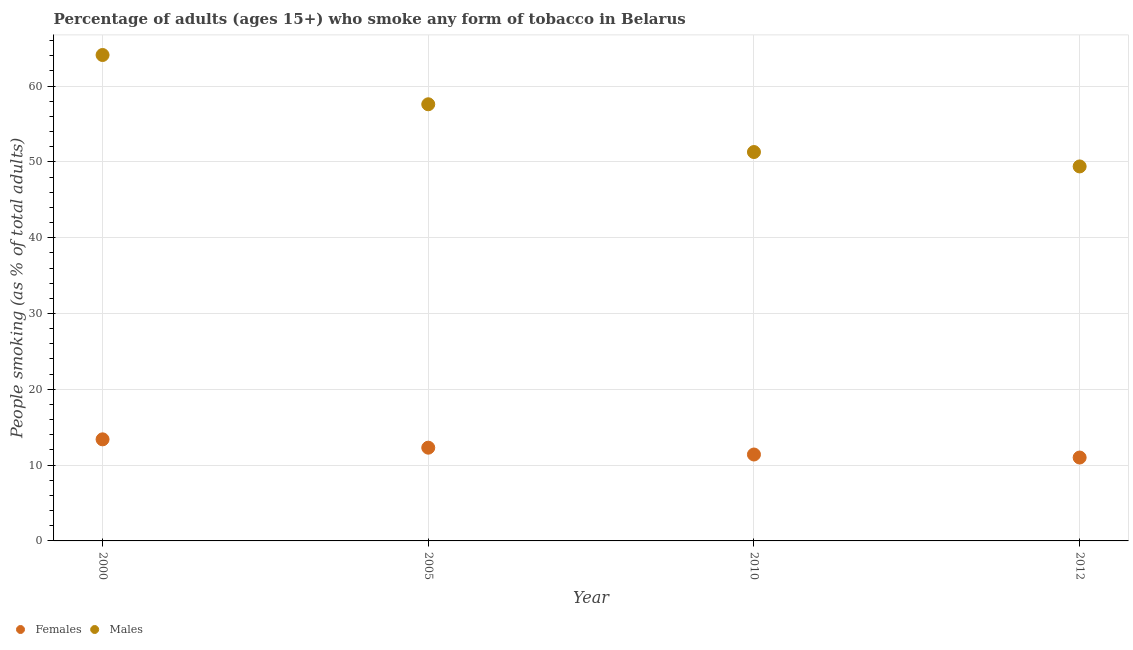Is the number of dotlines equal to the number of legend labels?
Offer a terse response. Yes. What is the percentage of females who smoke in 2010?
Your answer should be very brief. 11.4. Across all years, what is the minimum percentage of females who smoke?
Ensure brevity in your answer.  11. In which year was the percentage of females who smoke maximum?
Your answer should be very brief. 2000. In which year was the percentage of females who smoke minimum?
Your answer should be very brief. 2012. What is the total percentage of females who smoke in the graph?
Make the answer very short. 48.1. What is the difference between the percentage of females who smoke in 2005 and that in 2012?
Provide a short and direct response. 1.3. What is the difference between the percentage of males who smoke in 2012 and the percentage of females who smoke in 2005?
Offer a terse response. 37.1. What is the average percentage of females who smoke per year?
Keep it short and to the point. 12.03. In the year 2005, what is the difference between the percentage of males who smoke and percentage of females who smoke?
Your answer should be very brief. 45.3. In how many years, is the percentage of females who smoke greater than 44 %?
Offer a very short reply. 0. What is the ratio of the percentage of males who smoke in 2010 to that in 2012?
Give a very brief answer. 1.04. Is the percentage of females who smoke in 2010 less than that in 2012?
Provide a short and direct response. No. Is the difference between the percentage of males who smoke in 2000 and 2005 greater than the difference between the percentage of females who smoke in 2000 and 2005?
Your response must be concise. Yes. What is the difference between the highest and the second highest percentage of females who smoke?
Your response must be concise. 1.1. What is the difference between the highest and the lowest percentage of females who smoke?
Provide a short and direct response. 2.4. Is the sum of the percentage of males who smoke in 2005 and 2010 greater than the maximum percentage of females who smoke across all years?
Ensure brevity in your answer.  Yes. Is the percentage of males who smoke strictly greater than the percentage of females who smoke over the years?
Offer a very short reply. Yes. How many dotlines are there?
Give a very brief answer. 2. What is the difference between two consecutive major ticks on the Y-axis?
Keep it short and to the point. 10. Are the values on the major ticks of Y-axis written in scientific E-notation?
Your answer should be very brief. No. Does the graph contain any zero values?
Give a very brief answer. No. Does the graph contain grids?
Your answer should be compact. Yes. How many legend labels are there?
Offer a terse response. 2. What is the title of the graph?
Provide a succinct answer. Percentage of adults (ages 15+) who smoke any form of tobacco in Belarus. Does "Secondary Education" appear as one of the legend labels in the graph?
Provide a short and direct response. No. What is the label or title of the Y-axis?
Your answer should be very brief. People smoking (as % of total adults). What is the People smoking (as % of total adults) of Females in 2000?
Your response must be concise. 13.4. What is the People smoking (as % of total adults) of Males in 2000?
Your answer should be compact. 64.1. What is the People smoking (as % of total adults) of Males in 2005?
Provide a short and direct response. 57.6. What is the People smoking (as % of total adults) in Females in 2010?
Give a very brief answer. 11.4. What is the People smoking (as % of total adults) in Males in 2010?
Make the answer very short. 51.3. What is the People smoking (as % of total adults) of Females in 2012?
Make the answer very short. 11. What is the People smoking (as % of total adults) in Males in 2012?
Provide a succinct answer. 49.4. Across all years, what is the maximum People smoking (as % of total adults) in Males?
Offer a terse response. 64.1. Across all years, what is the minimum People smoking (as % of total adults) of Females?
Offer a terse response. 11. Across all years, what is the minimum People smoking (as % of total adults) of Males?
Your answer should be very brief. 49.4. What is the total People smoking (as % of total adults) in Females in the graph?
Keep it short and to the point. 48.1. What is the total People smoking (as % of total adults) of Males in the graph?
Keep it short and to the point. 222.4. What is the difference between the People smoking (as % of total adults) in Males in 2000 and that in 2005?
Keep it short and to the point. 6.5. What is the difference between the People smoking (as % of total adults) in Males in 2000 and that in 2012?
Provide a succinct answer. 14.7. What is the difference between the People smoking (as % of total adults) in Females in 2005 and that in 2010?
Provide a succinct answer. 0.9. What is the difference between the People smoking (as % of total adults) in Males in 2005 and that in 2010?
Give a very brief answer. 6.3. What is the difference between the People smoking (as % of total adults) of Males in 2005 and that in 2012?
Ensure brevity in your answer.  8.2. What is the difference between the People smoking (as % of total adults) in Females in 2010 and that in 2012?
Offer a very short reply. 0.4. What is the difference between the People smoking (as % of total adults) in Males in 2010 and that in 2012?
Keep it short and to the point. 1.9. What is the difference between the People smoking (as % of total adults) of Females in 2000 and the People smoking (as % of total adults) of Males in 2005?
Ensure brevity in your answer.  -44.2. What is the difference between the People smoking (as % of total adults) of Females in 2000 and the People smoking (as % of total adults) of Males in 2010?
Provide a short and direct response. -37.9. What is the difference between the People smoking (as % of total adults) in Females in 2000 and the People smoking (as % of total adults) in Males in 2012?
Your response must be concise. -36. What is the difference between the People smoking (as % of total adults) of Females in 2005 and the People smoking (as % of total adults) of Males in 2010?
Give a very brief answer. -39. What is the difference between the People smoking (as % of total adults) of Females in 2005 and the People smoking (as % of total adults) of Males in 2012?
Keep it short and to the point. -37.1. What is the difference between the People smoking (as % of total adults) in Females in 2010 and the People smoking (as % of total adults) in Males in 2012?
Your answer should be very brief. -38. What is the average People smoking (as % of total adults) of Females per year?
Make the answer very short. 12.03. What is the average People smoking (as % of total adults) of Males per year?
Provide a short and direct response. 55.6. In the year 2000, what is the difference between the People smoking (as % of total adults) of Females and People smoking (as % of total adults) of Males?
Your answer should be compact. -50.7. In the year 2005, what is the difference between the People smoking (as % of total adults) of Females and People smoking (as % of total adults) of Males?
Ensure brevity in your answer.  -45.3. In the year 2010, what is the difference between the People smoking (as % of total adults) of Females and People smoking (as % of total adults) of Males?
Provide a short and direct response. -39.9. In the year 2012, what is the difference between the People smoking (as % of total adults) in Females and People smoking (as % of total adults) in Males?
Make the answer very short. -38.4. What is the ratio of the People smoking (as % of total adults) of Females in 2000 to that in 2005?
Ensure brevity in your answer.  1.09. What is the ratio of the People smoking (as % of total adults) in Males in 2000 to that in 2005?
Give a very brief answer. 1.11. What is the ratio of the People smoking (as % of total adults) of Females in 2000 to that in 2010?
Offer a very short reply. 1.18. What is the ratio of the People smoking (as % of total adults) of Males in 2000 to that in 2010?
Make the answer very short. 1.25. What is the ratio of the People smoking (as % of total adults) in Females in 2000 to that in 2012?
Keep it short and to the point. 1.22. What is the ratio of the People smoking (as % of total adults) in Males in 2000 to that in 2012?
Keep it short and to the point. 1.3. What is the ratio of the People smoking (as % of total adults) of Females in 2005 to that in 2010?
Your response must be concise. 1.08. What is the ratio of the People smoking (as % of total adults) of Males in 2005 to that in 2010?
Keep it short and to the point. 1.12. What is the ratio of the People smoking (as % of total adults) of Females in 2005 to that in 2012?
Your answer should be compact. 1.12. What is the ratio of the People smoking (as % of total adults) of Males in 2005 to that in 2012?
Your answer should be very brief. 1.17. What is the ratio of the People smoking (as % of total adults) in Females in 2010 to that in 2012?
Make the answer very short. 1.04. What is the difference between the highest and the second highest People smoking (as % of total adults) in Females?
Make the answer very short. 1.1. What is the difference between the highest and the lowest People smoking (as % of total adults) in Females?
Give a very brief answer. 2.4. What is the difference between the highest and the lowest People smoking (as % of total adults) in Males?
Offer a terse response. 14.7. 